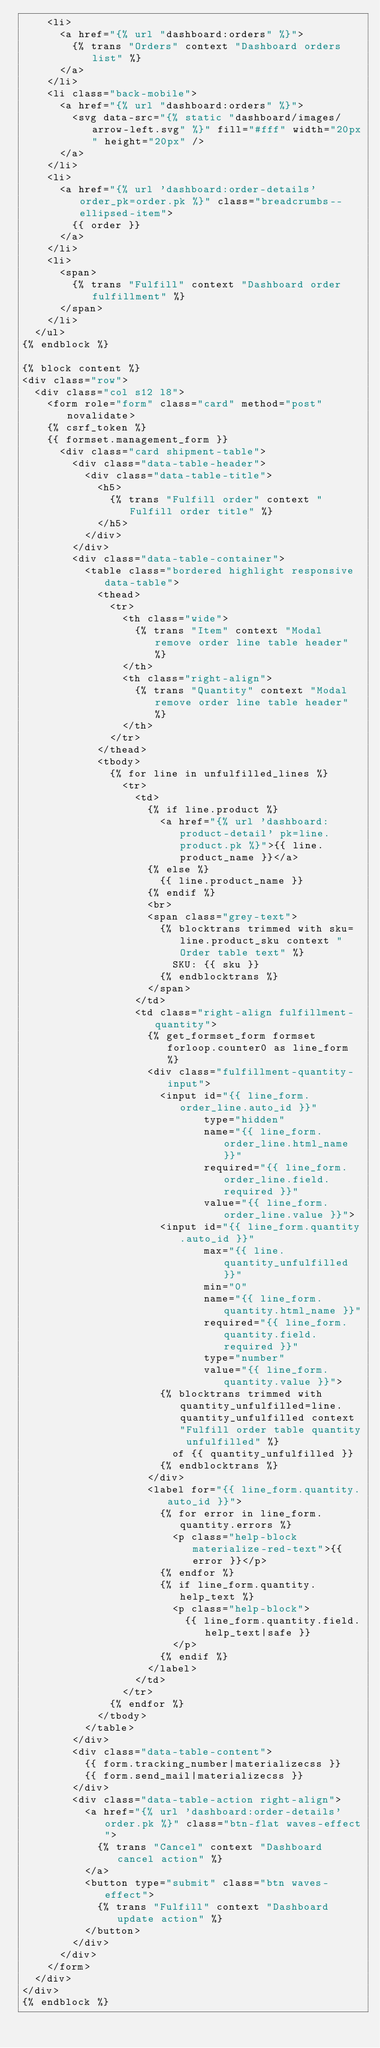<code> <loc_0><loc_0><loc_500><loc_500><_HTML_>    <li>
      <a href="{% url "dashboard:orders" %}">
        {% trans "Orders" context "Dashboard orders list" %}
      </a>
    </li>
    <li class="back-mobile">
      <a href="{% url "dashboard:orders" %}">
        <svg data-src="{% static "dashboard/images/arrow-left.svg" %}" fill="#fff" width="20px" height="20px" />
      </a>
    </li>
    <li>
      <a href="{% url 'dashboard:order-details' order_pk=order.pk %}" class="breadcrumbs--ellipsed-item">
        {{ order }}
      </a>
    </li>
    <li>
      <span>
        {% trans "Fulfill" context "Dashboard order fulfillment" %}
      </span>
    </li>
  </ul>
{% endblock %}

{% block content %}
<div class="row">
  <div class="col s12 l8">
    <form role="form" class="card" method="post" novalidate>
    {% csrf_token %}
    {{ formset.management_form }}
      <div class="card shipment-table">
        <div class="data-table-header">
          <div class="data-table-title">
            <h5>
              {% trans "Fulfill order" context "Fulfill order title" %}
            </h5>
          </div>
        </div>
        <div class="data-table-container">
          <table class="bordered highlight responsive data-table">
            <thead>
              <tr>
                <th class="wide">
                  {% trans "Item" context "Modal remove order line table header" %}
                </th>
                <th class="right-align">
                  {% trans "Quantity" context "Modal remove order line table header" %}
                </th>
              </tr>
            </thead>
            <tbody>
              {% for line in unfulfilled_lines %}
                <tr>
                  <td>
                    {% if line.product %}
                      <a href="{% url 'dashboard:product-detail' pk=line.product.pk %}">{{ line.product_name }}</a>
                    {% else %}
                      {{ line.product_name }}
                    {% endif %}
                    <br>
                    <span class="grey-text">
                      {% blocktrans trimmed with sku=line.product_sku context "Order table text" %}
                        SKU: {{ sku }}
                      {% endblocktrans %}
                    </span>
                  </td>
                  <td class="right-align fulfillment-quantity">
                    {% get_formset_form formset forloop.counter0 as line_form %}
                    <div class="fulfillment-quantity-input">
                      <input id="{{ line_form.order_line.auto_id }}"
                             type="hidden"
                             name="{{ line_form.order_line.html_name }}"
                             required="{{ line_form.order_line.field.required }}"
                             value="{{ line_form.order_line.value }}">
                      <input id="{{ line_form.quantity.auto_id }}"
                             max="{{ line.quantity_unfulfilled }}"
                             min="0"
                             name="{{ line_form.quantity.html_name }}"
                             required="{{ line_form.quantity.field.required }}"
                             type="number"
                             value="{{ line_form.quantity.value }}">
                      {% blocktrans trimmed with quantity_unfulfilled=line.quantity_unfulfilled context "Fulfill order table quantity unfulfilled" %}
                        of {{ quantity_unfulfilled }}
                      {% endblocktrans %}
                    </div>
                    <label for="{{ line_form.quantity.auto_id }}">
                      {% for error in line_form.quantity.errors %}
                        <p class="help-block materialize-red-text">{{ error }}</p>
                      {% endfor %}
                      {% if line_form.quantity.help_text %}
                        <p class="help-block">
                          {{ line_form.quantity.field.help_text|safe }}
                        </p>
                      {% endif %}
                    </label>
                  </td>
                </tr>
              {% endfor %}
            </tbody>
          </table>
        </div>
        <div class="data-table-content">
          {{ form.tracking_number|materializecss }}
          {{ form.send_mail|materializecss }}
        </div>
        <div class="data-table-action right-align">
          <a href="{% url 'dashboard:order-details' order.pk %}" class="btn-flat waves-effect">
            {% trans "Cancel" context "Dashboard cancel action" %}
          </a>
          <button type="submit" class="btn waves-effect">
            {% trans "Fulfill" context "Dashboard update action" %}
          </button>
        </div>
      </div>
    </form>
  </div>
</div>
{% endblock %}
</code> 